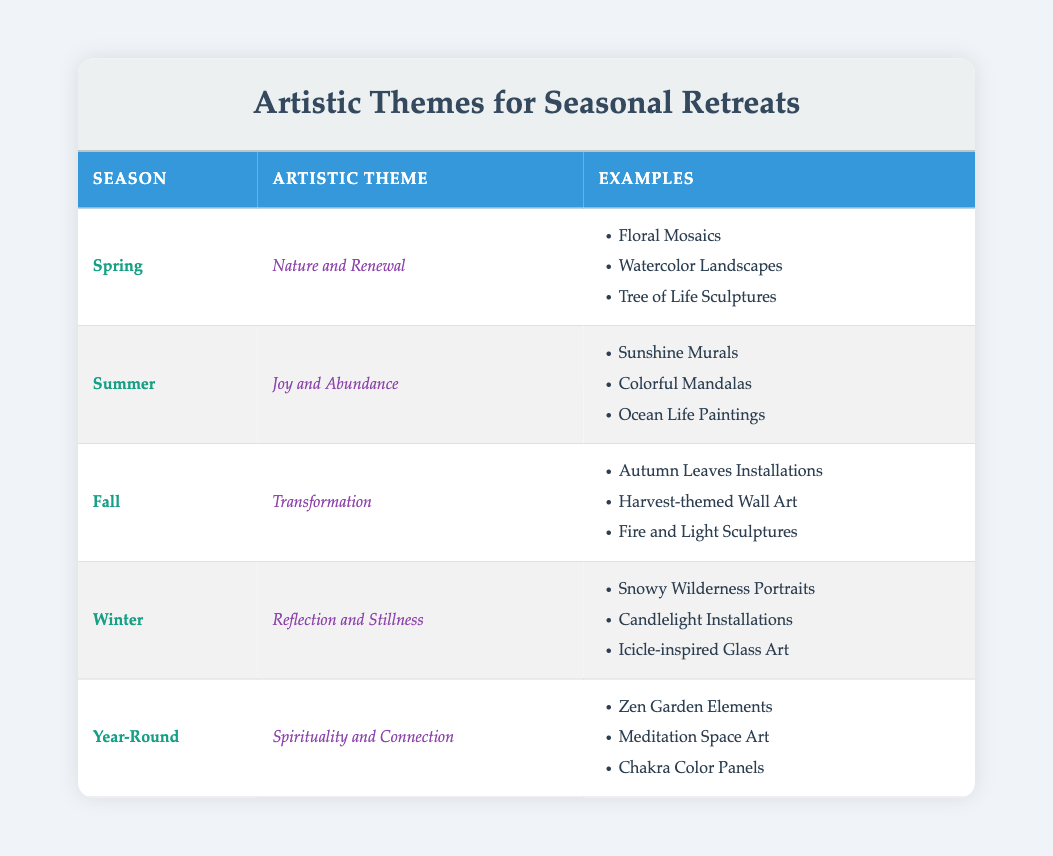What artistic theme is associated with Spring? The table shows that the artistic theme related to Spring is "Nature and Renewal". This information can be found directly in the Spring row under the "Artistic Theme" column.
Answer: Nature and Renewal Which season is associated with the theme "Reflection and Stillness"? By looking at the table, we can find that "Reflection and Stillness" is the artistic theme for Winter, which is directly indicated in the corresponding row for Winter.
Answer: Winter How many artistic themes are listed in the table? The table lists five different artistic themes: "Nature and Renewal", "Joy and Abundance", "Transformation", "Reflection and Stillness", and "Spirituality and Connection". Thus, the total count is five.
Answer: 5 Are there any artistic themes that incorporate the idea of spirituality? The table shows that "Spirituality and Connection" is listed as an artistic theme for the Year-Round season, suggesting that this theme incorporates spirituality. The answer is thus yes.
Answer: Yes Which season has the artistic theme associated with transformation? According to the table, Fall is associated with the artistic theme of Transformation, which is clearly stated in the Fall row.
Answer: Fall What is the average number of artistic themes per season, considering only seasonal themes? There are four seasons (Spring, Summer, Fall, and Winter) with one theme each. Thus, the average is 4 themes divided by 4 seasons (4/4), which equals 1 theme per season.
Answer: 1 Does Summer feature artistic themes related to nature? The artistic theme for Summer is "Joy and Abundance". Since this does not reflect a nature focus, the answer is no.
Answer: No Which season has the most examples listed under its artistic theme? Each seasonal theme has three examples listed. Therefore, each of the seasons (Spring, Summer, Fall, and Winter) has an equal number of examples.
Answer: All seasons have three examples What artistic theme corresponds to the idea of joy and abundance? The table specifies that the theme corresponding to joy and abundance is "Joy and Abundance", which is found in the Summer row of the table.
Answer: Joy and Abundance 